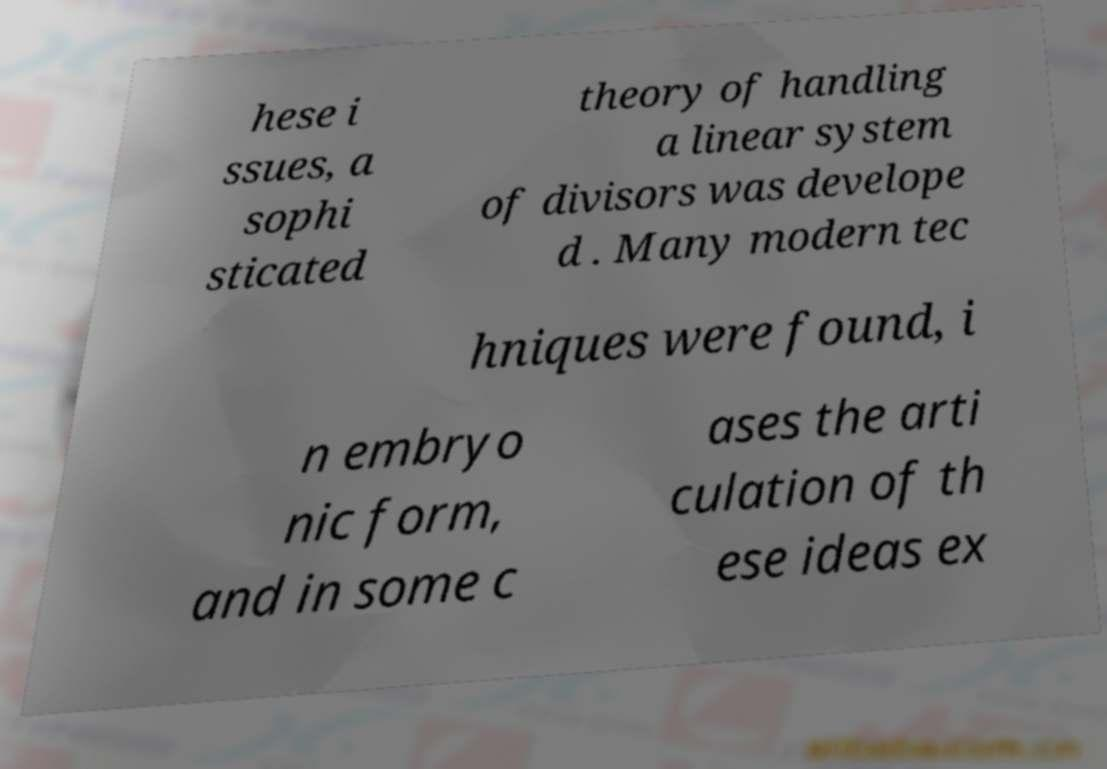What messages or text are displayed in this image? I need them in a readable, typed format. hese i ssues, a sophi sticated theory of handling a linear system of divisors was develope d . Many modern tec hniques were found, i n embryo nic form, and in some c ases the arti culation of th ese ideas ex 